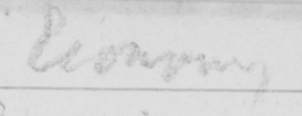Please transcribe the handwritten text in this image. Economy 